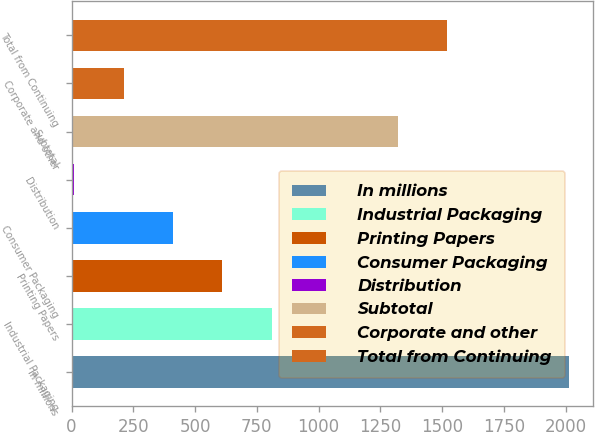Convert chart. <chart><loc_0><loc_0><loc_500><loc_500><bar_chart><fcel>In millions<fcel>Industrial Packaging<fcel>Printing Papers<fcel>Consumer Packaging<fcel>Distribution<fcel>Subtotal<fcel>Corporate and other<fcel>Total from Continuing<nl><fcel>2012<fcel>810.8<fcel>610.6<fcel>410.4<fcel>10<fcel>1320<fcel>210.2<fcel>1520.2<nl></chart> 